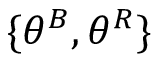Convert formula to latex. <formula><loc_0><loc_0><loc_500><loc_500>\{ \theta ^ { B } , \theta ^ { R } \}</formula> 